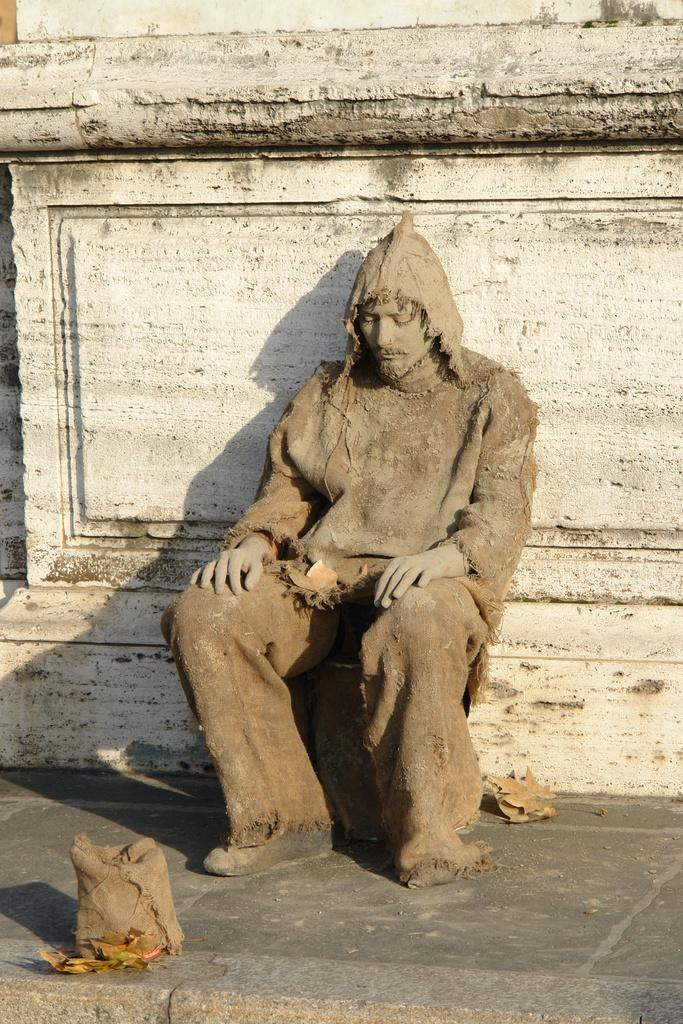What is the man in the image doing? The man is sitting in the image. What can be seen behind the man? There is a wall in the image. What is on the floor in the image? Dried leaves are present on the floor in the image. What type of linen is draped over the man's shoulder in the image? There is no linen draped over the man's shoulder in the image. What badge is the man wearing in the image? There is no badge visible on the man in the image. 